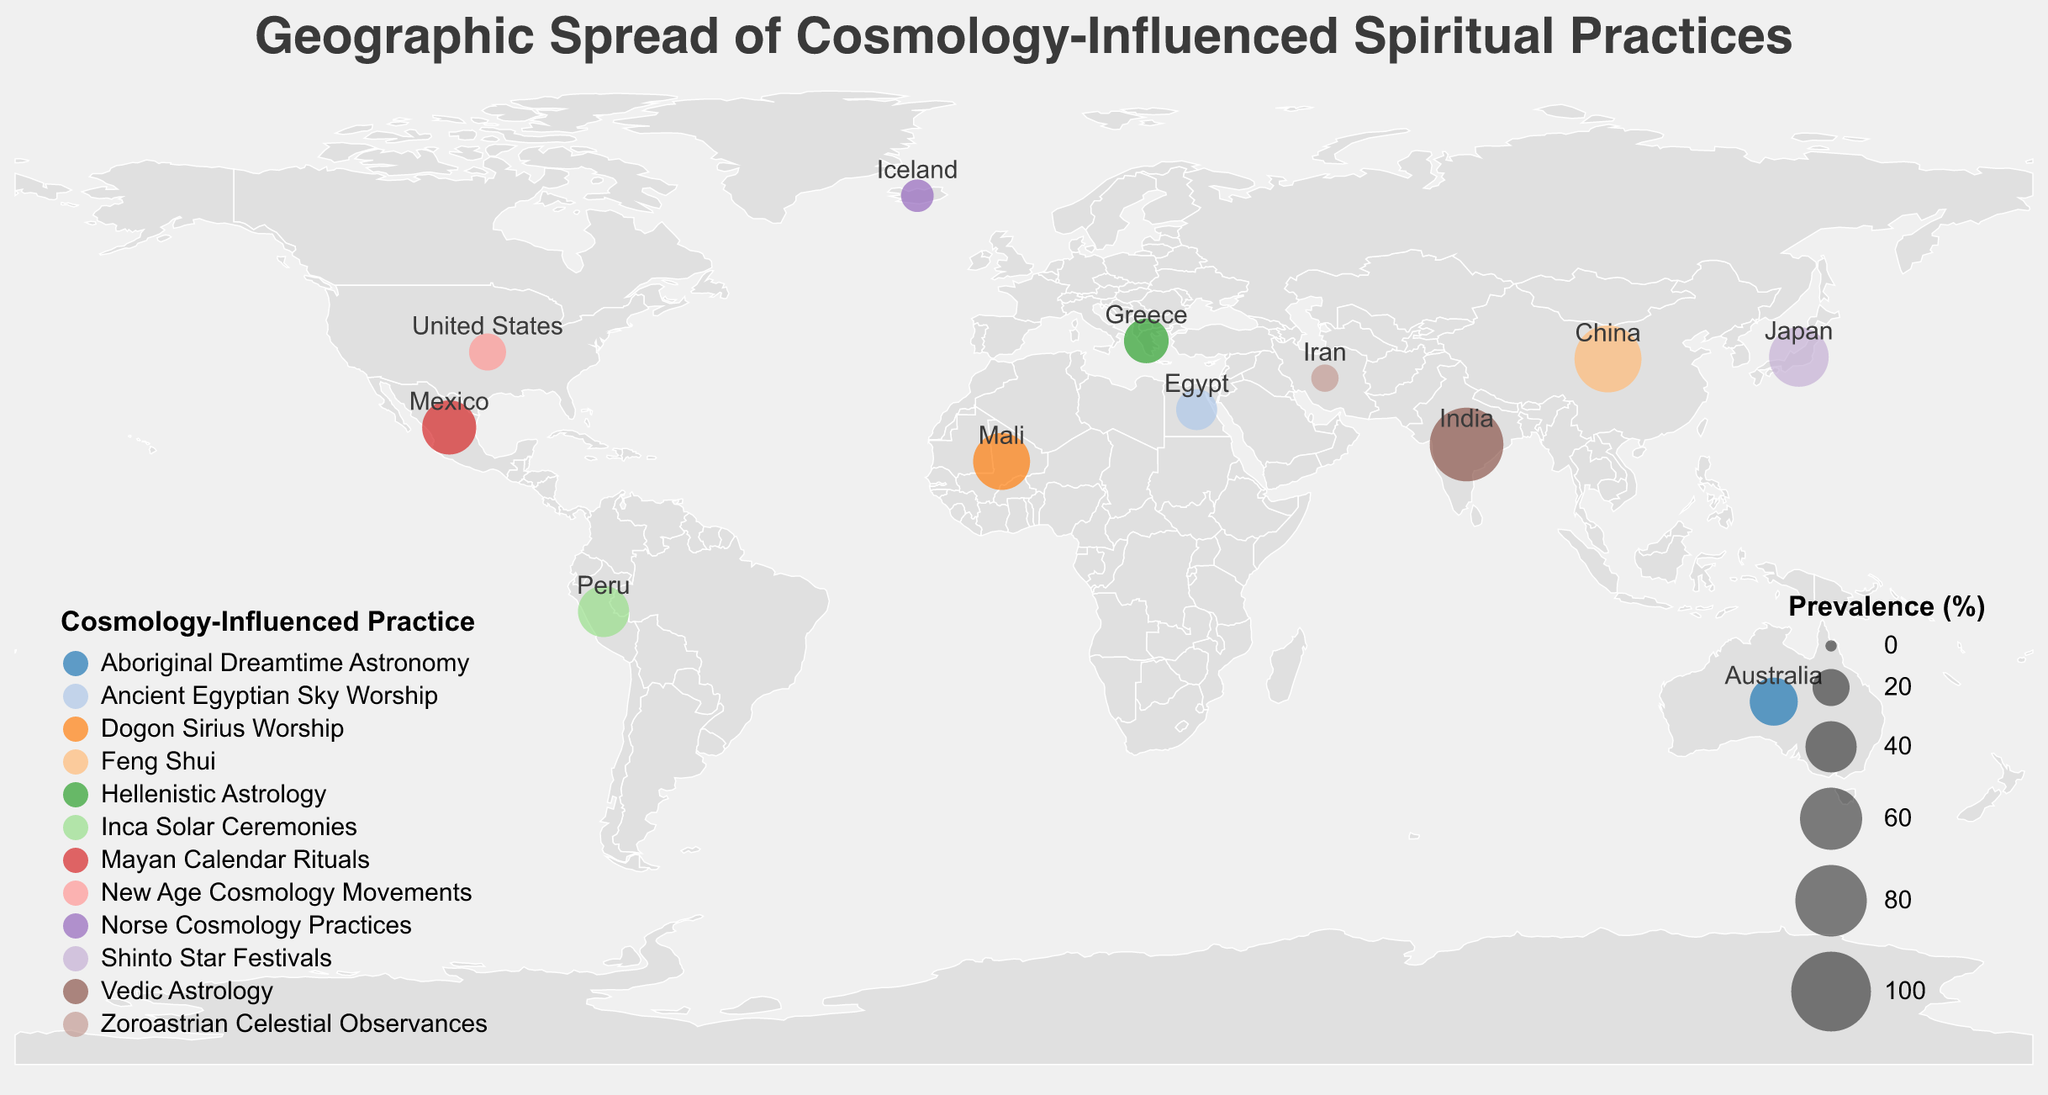What is the title of the figure? The title is usually displayed prominently at the top of the figure. It is intended to provide a brief description of what the figure represents. In this case, the title is shown as "Geographic Spread of Cosmology-Influenced Spiritual Practices".
Answer: Geographic Spread of Cosmology-Influenced Spiritual Practices Which country has the highest prevalence of cosmology-influenced spiritual practices? To find the country with the highest prevalence, we need to identify the data point with the largest circle size. According to the figure and the data, India, with "Vedic Astrology" having an 85% prevalence, has the highest prevalence.
Answer: India What is the prevalence of New Age Cosmology Movements in the United States? Identify the circle corresponding to the United States and check its associated prevalence value. According to the figure, the prevalence of New Age Cosmology Movements in the United States is 20%.
Answer: 20% How many countries have cosmology-influenced practices with a prevalence of 50% or higher? Examine the figure to count the number of circles where the prevalence is 50% or more. From the data: India (85%), China (70%), Japan (55%), and Mali (50%). There are 4 countries with such high prevalence.
Answer: 4 Which cosmology-influenced spiritual practice is more prevalent: Mayan Calendar Rituals in Mexico or Inca Solar Ceremonies in Peru? To compare the prevalence, look at the prevalence values of both practices. Mayan Calendar Rituals in Mexico has a prevalence of 45%, while Inca Solar Ceremonies in Peru has a prevalence of 40%. Thus, Mayan Calendar Rituals are more prevalent.
Answer: Mayan Calendar Rituals What is the average prevalence of cosmology-influenced spiritual practices across all listed countries? To calculate the average prevalence, sum the prevalence values for all listed countries and divide by the number of countries. (85+30+70+45+25+40+55+20+15+35+10+50)/12 = 480/12 = 40
Answer: 40 Which continent has the most diverse set of cosmology-influenced spiritual practices based on the figure? Examine the diversity of practices by identifying how many different practices are represented on each continent. Given countries like India, Iran, and China in Asia with varying practices like Vedic Astrology, Zoroastrian Celestial Observances, and Feng Shui, Asia appears to have the most diverse set of practices.
Answer: Asia Compare the prevalence of cosmology-influenced practices in Egypt and Iceland. Which one is higher and by how much? Look at the prevalence values for Egypt (25%) and Iceland (15%) and subtract the smaller from the larger. The practice in Egypt is higher by 25 - 15 = 10%.
Answer: Egypt, 10% What cosmology-influenced practice is associated with the Dogon people in Mali and what is its prevalence? Find Mali on the map, identify the practice associated with it and its prevalence. According to the figure, the Dogon people in Mali practice "Dogon Sirius Worship" with a prevalence of 50%.
Answer: Dogon Sirius Worship, 50% Which country has the least prevalence of cosmology-influenced spiritual practices and what is the practice called? Identify the country with the smallest circle and check its associated practice. According to the data, Iran has the least prevalence at 10%, associated with "Zoroastrian Celestial Observances".
Answer: Iran, Zoroastrian Celestial Observances 